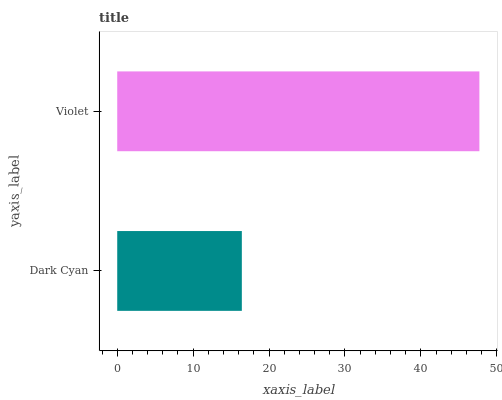Is Dark Cyan the minimum?
Answer yes or no. Yes. Is Violet the maximum?
Answer yes or no. Yes. Is Violet the minimum?
Answer yes or no. No. Is Violet greater than Dark Cyan?
Answer yes or no. Yes. Is Dark Cyan less than Violet?
Answer yes or no. Yes. Is Dark Cyan greater than Violet?
Answer yes or no. No. Is Violet less than Dark Cyan?
Answer yes or no. No. Is Violet the high median?
Answer yes or no. Yes. Is Dark Cyan the low median?
Answer yes or no. Yes. Is Dark Cyan the high median?
Answer yes or no. No. Is Violet the low median?
Answer yes or no. No. 